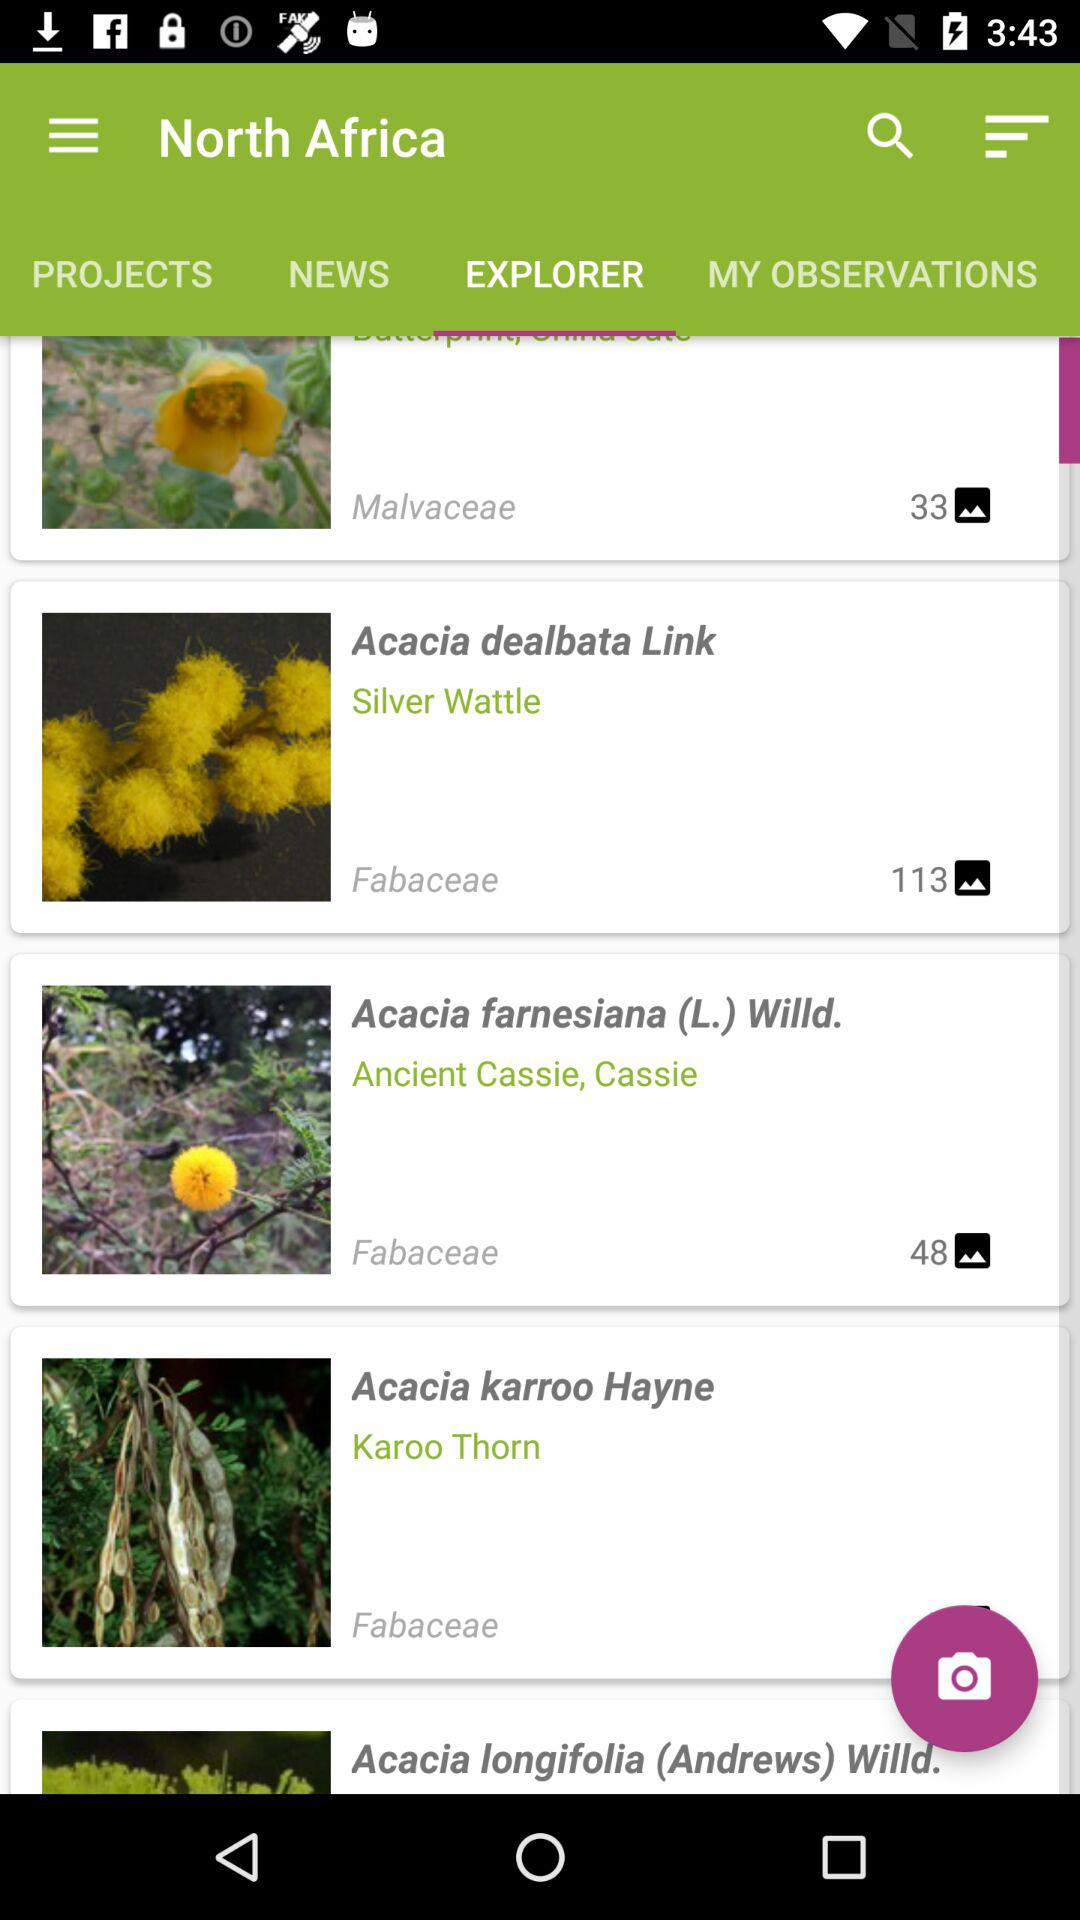How many images are there for "Acacia dealbata Link"? There are 113 images. 